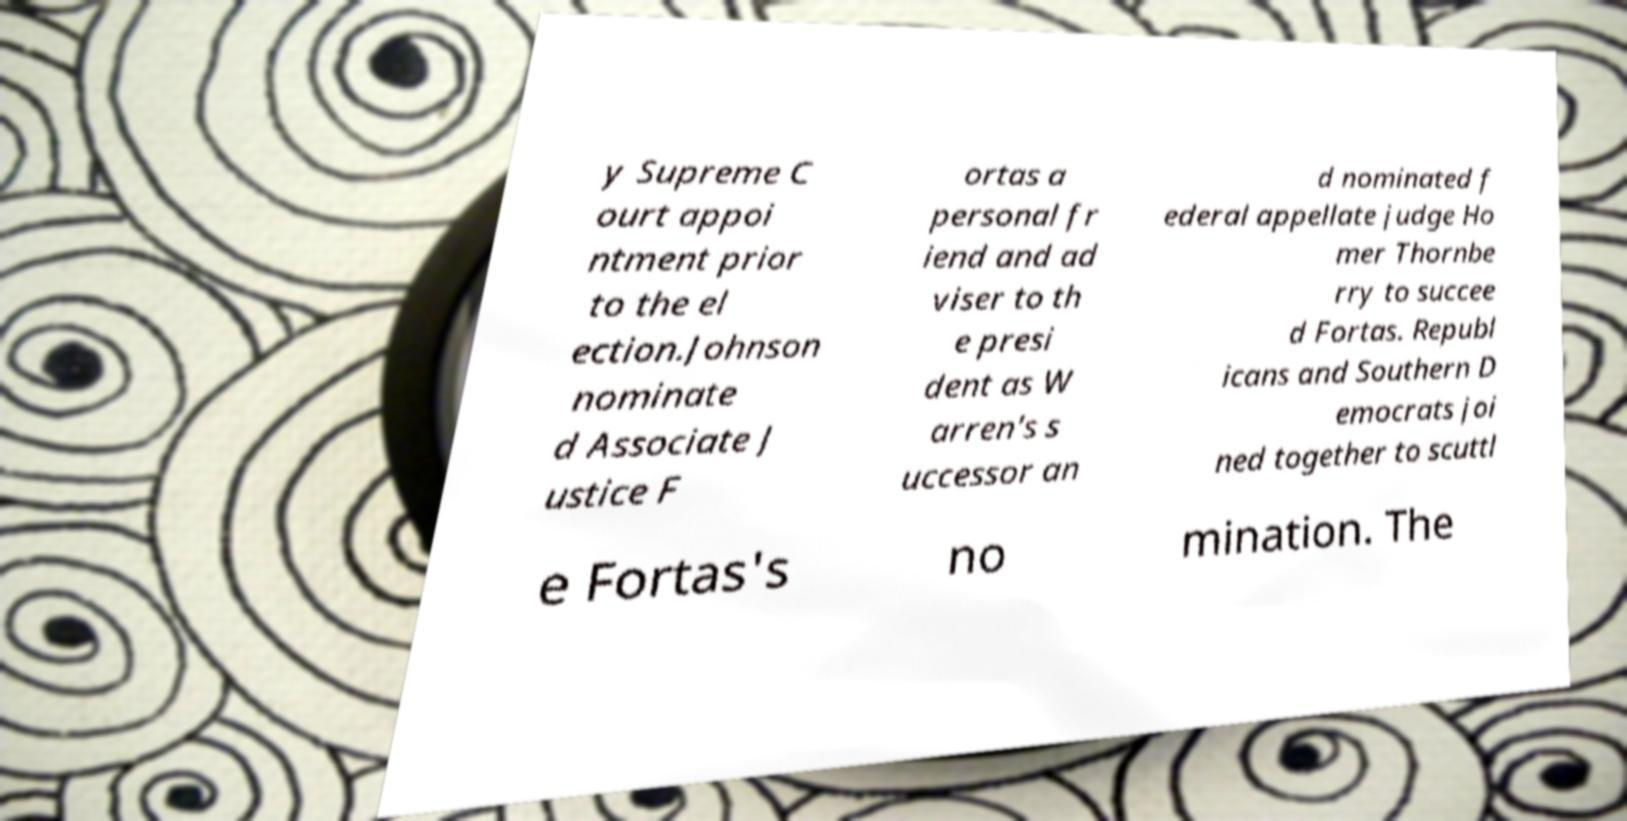Could you extract and type out the text from this image? y Supreme C ourt appoi ntment prior to the el ection.Johnson nominate d Associate J ustice F ortas a personal fr iend and ad viser to th e presi dent as W arren's s uccessor an d nominated f ederal appellate judge Ho mer Thornbe rry to succee d Fortas. Republ icans and Southern D emocrats joi ned together to scuttl e Fortas's no mination. The 